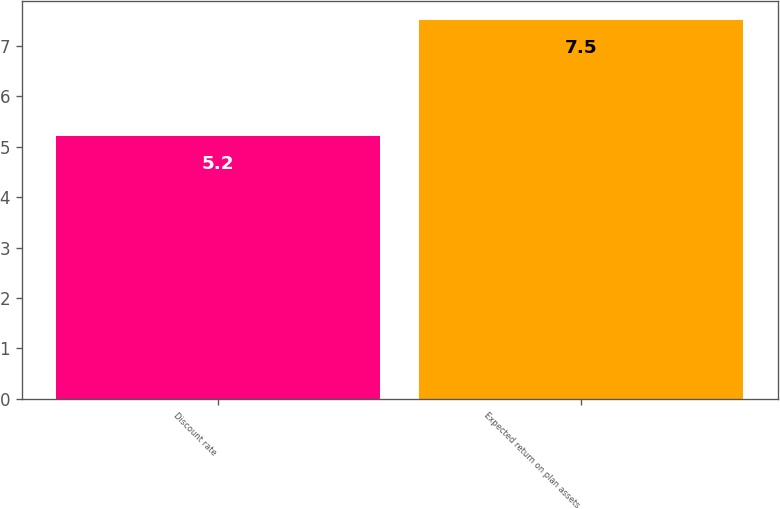<chart> <loc_0><loc_0><loc_500><loc_500><bar_chart><fcel>Discount rate<fcel>Expected return on plan assets<nl><fcel>5.2<fcel>7.5<nl></chart> 